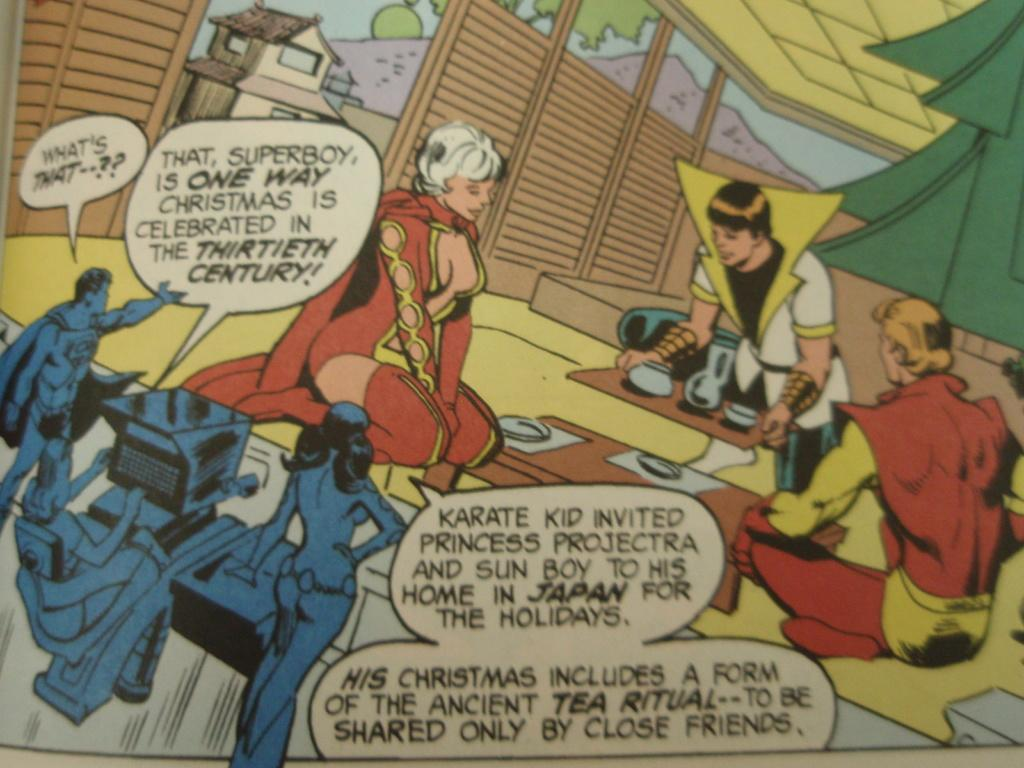Provide a one-sentence caption for the provided image. Three people are watching three other people on a monitor and Superboy is saying "What's That". 